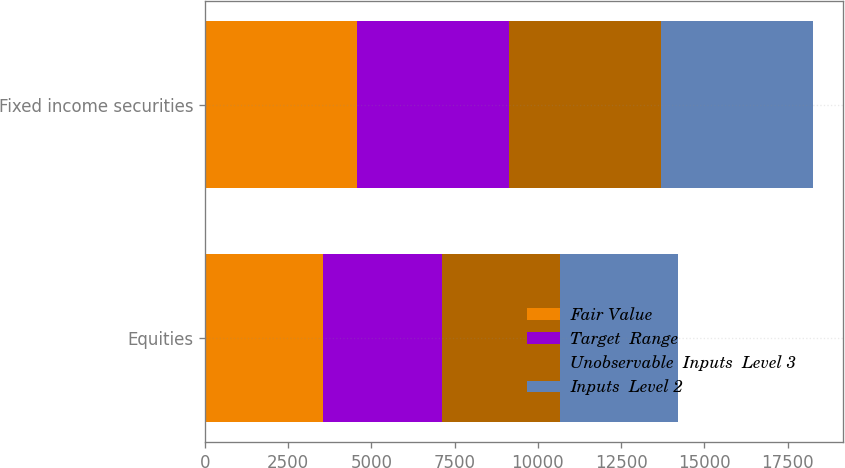Convert chart. <chart><loc_0><loc_0><loc_500><loc_500><stacked_bar_chart><ecel><fcel>Equities<fcel>Fixed income securities<nl><fcel>Fair Value<fcel>3555<fcel>4565<nl><fcel>Target  Range<fcel>3555<fcel>4565<nl><fcel>Unobservable  Inputs  Level 3<fcel>3555<fcel>4565<nl><fcel>Inputs  Level 2<fcel>3555<fcel>4565<nl></chart> 